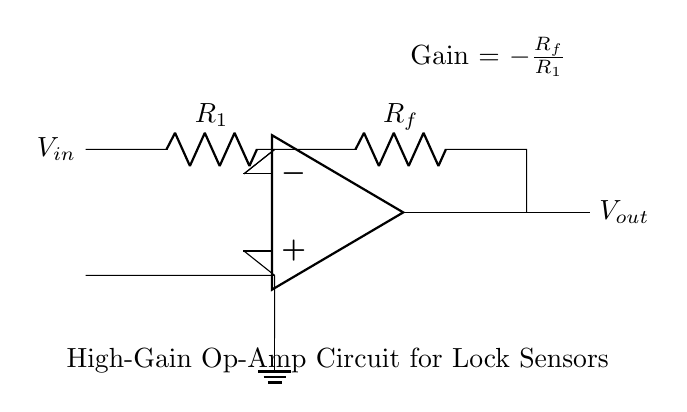What is the type of the operational amplifier used in this circuit? The circuit diagram specifically labels the op-amp symbol, indicating that it is a high-gain operational amplifier.
Answer: high-gain operational amplifier What components are used in the feedback loop? The feedback loop consists of a resistor labeled as R_f, connecting the output of the op-amp back to the inverting terminal.
Answer: R_f What is the input voltage of this circuit? The input voltage is represented by the label V_in on the left side of the circuit diagram.
Answer: V_in What is the gain formula for this amplifier? The gain formula is provided in the diagram as Gain = -R_f/R_1, showing how the gain relates to the resistors in the circuit.
Answer: -R_f/R_1 If R_f is 10k ohms and R_1 is 1k ohms, what is the gain? To calculate the gain, substitute R_f = 10k and R_1 = 1k into the formula: Gain = -10k/1k = -10.
Answer: -10 How does the feedback resistor R_f affect the circuit's behavior? The feedback resistor R_f influences the amount of gain this op-amp circuit provides; a larger R_f results in a higher gain.
Answer: Higher gain What happens to the output voltage if V_in is increased? As V_in increases, the output voltage V_out will also increase proportionally based on the gain, following the relationship defined by the circuit.
Answer: V_out increases 